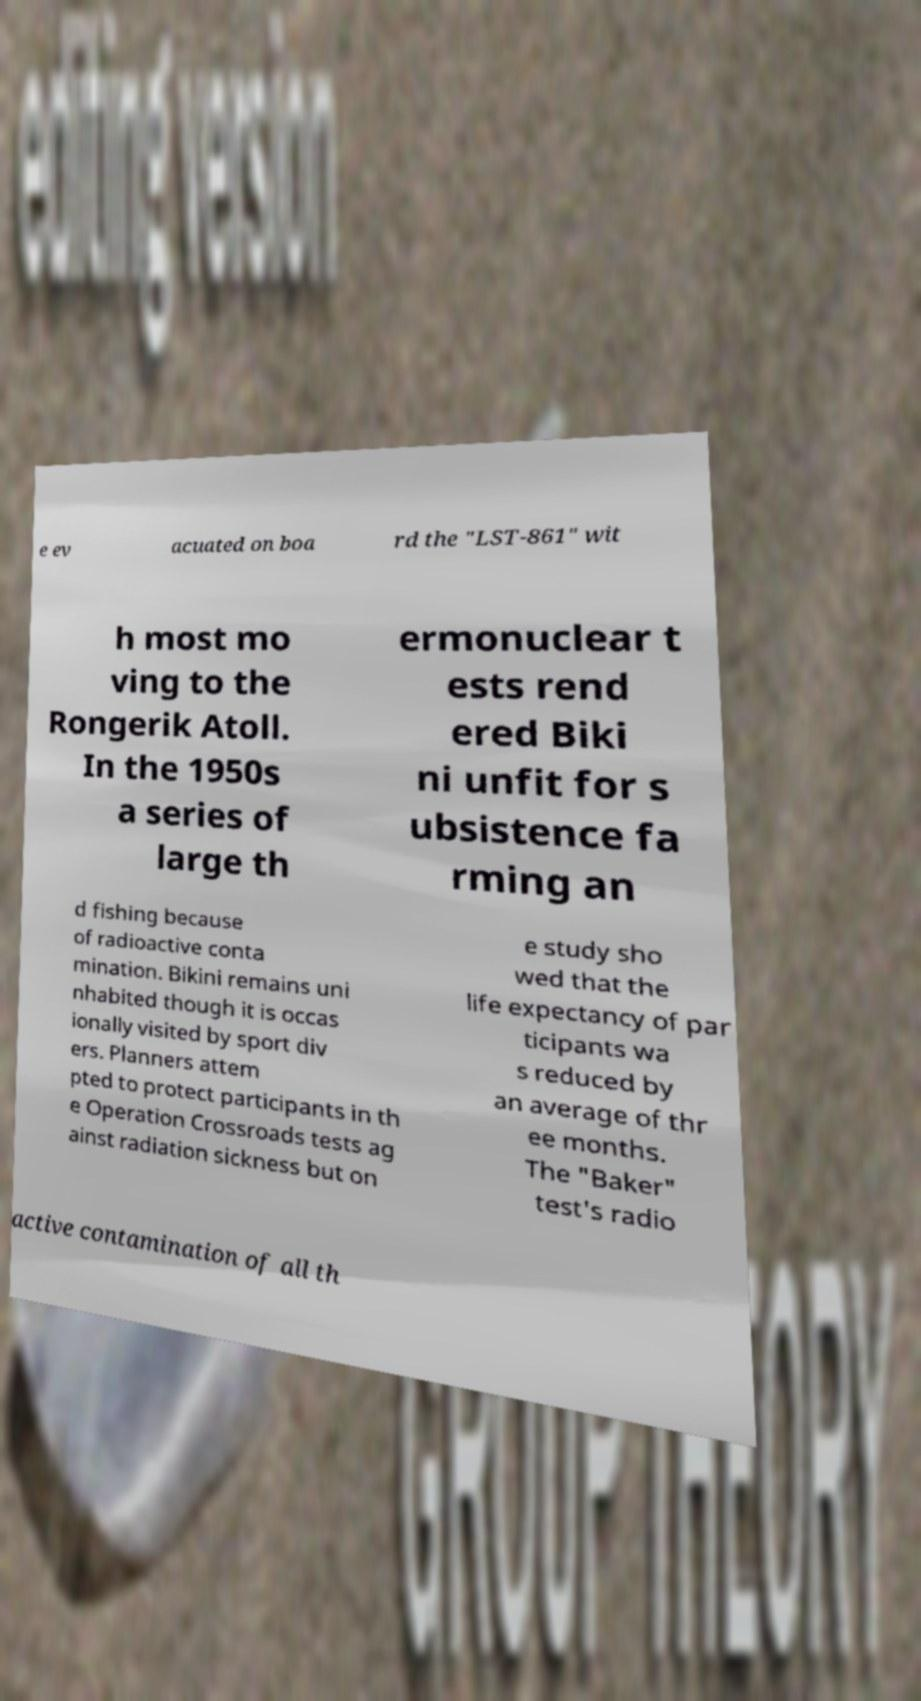Could you assist in decoding the text presented in this image and type it out clearly? e ev acuated on boa rd the "LST-861" wit h most mo ving to the Rongerik Atoll. In the 1950s a series of large th ermonuclear t ests rend ered Biki ni unfit for s ubsistence fa rming an d fishing because of radioactive conta mination. Bikini remains uni nhabited though it is occas ionally visited by sport div ers. Planners attem pted to protect participants in th e Operation Crossroads tests ag ainst radiation sickness but on e study sho wed that the life expectancy of par ticipants wa s reduced by an average of thr ee months. The "Baker" test's radio active contamination of all th 